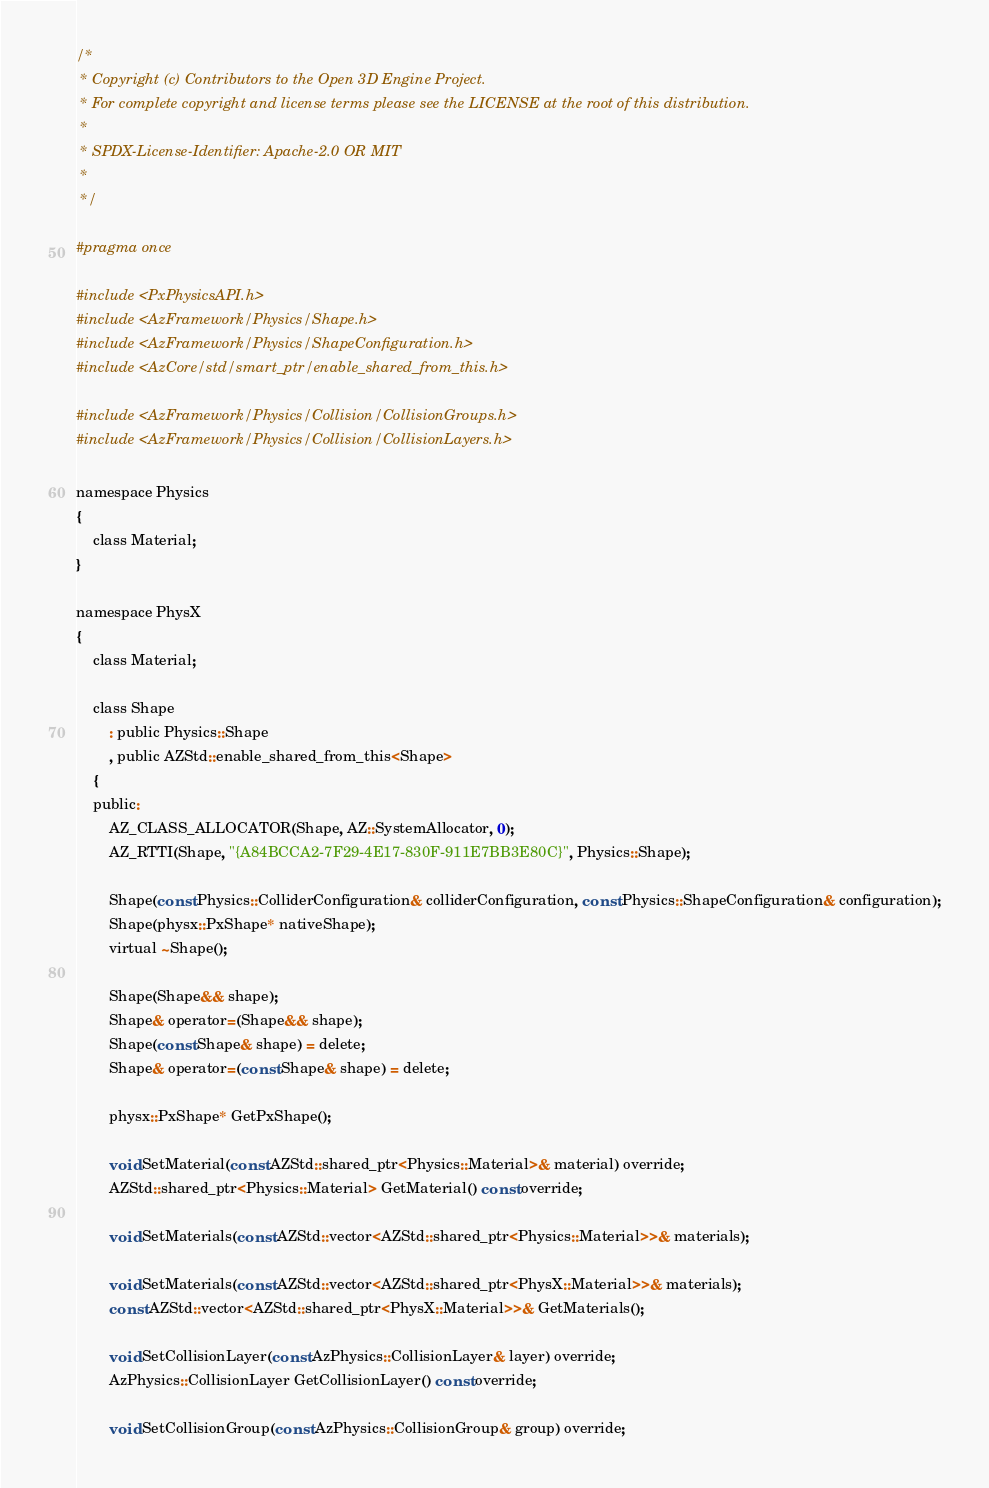Convert code to text. <code><loc_0><loc_0><loc_500><loc_500><_C_>/*
 * Copyright (c) Contributors to the Open 3D Engine Project.
 * For complete copyright and license terms please see the LICENSE at the root of this distribution.
 *
 * SPDX-License-Identifier: Apache-2.0 OR MIT
 *
 */

#pragma once

#include <PxPhysicsAPI.h>
#include <AzFramework/Physics/Shape.h>
#include <AzFramework/Physics/ShapeConfiguration.h>
#include <AzCore/std/smart_ptr/enable_shared_from_this.h>

#include <AzFramework/Physics/Collision/CollisionGroups.h>
#include <AzFramework/Physics/Collision/CollisionLayers.h>

namespace Physics
{
    class Material;
}

namespace PhysX
{
    class Material;

    class Shape
        : public Physics::Shape
        , public AZStd::enable_shared_from_this<Shape>
    {
    public:
        AZ_CLASS_ALLOCATOR(Shape, AZ::SystemAllocator, 0);
        AZ_RTTI(Shape, "{A84BCCA2-7F29-4E17-830F-911E7BB3E80C}", Physics::Shape);

        Shape(const Physics::ColliderConfiguration& colliderConfiguration, const Physics::ShapeConfiguration& configuration);
        Shape(physx::PxShape* nativeShape);
        virtual ~Shape();

        Shape(Shape&& shape);
        Shape& operator=(Shape&& shape);
        Shape(const Shape& shape) = delete;
        Shape& operator=(const Shape& shape) = delete;

        physx::PxShape* GetPxShape();

        void SetMaterial(const AZStd::shared_ptr<Physics::Material>& material) override;
        AZStd::shared_ptr<Physics::Material> GetMaterial() const override;

        void SetMaterials(const AZStd::vector<AZStd::shared_ptr<Physics::Material>>& materials);

        void SetMaterials(const AZStd::vector<AZStd::shared_ptr<PhysX::Material>>& materials);
        const AZStd::vector<AZStd::shared_ptr<PhysX::Material>>& GetMaterials();

        void SetCollisionLayer(const AzPhysics::CollisionLayer& layer) override;
        AzPhysics::CollisionLayer GetCollisionLayer() const override;

        void SetCollisionGroup(const AzPhysics::CollisionGroup& group) override;</code> 